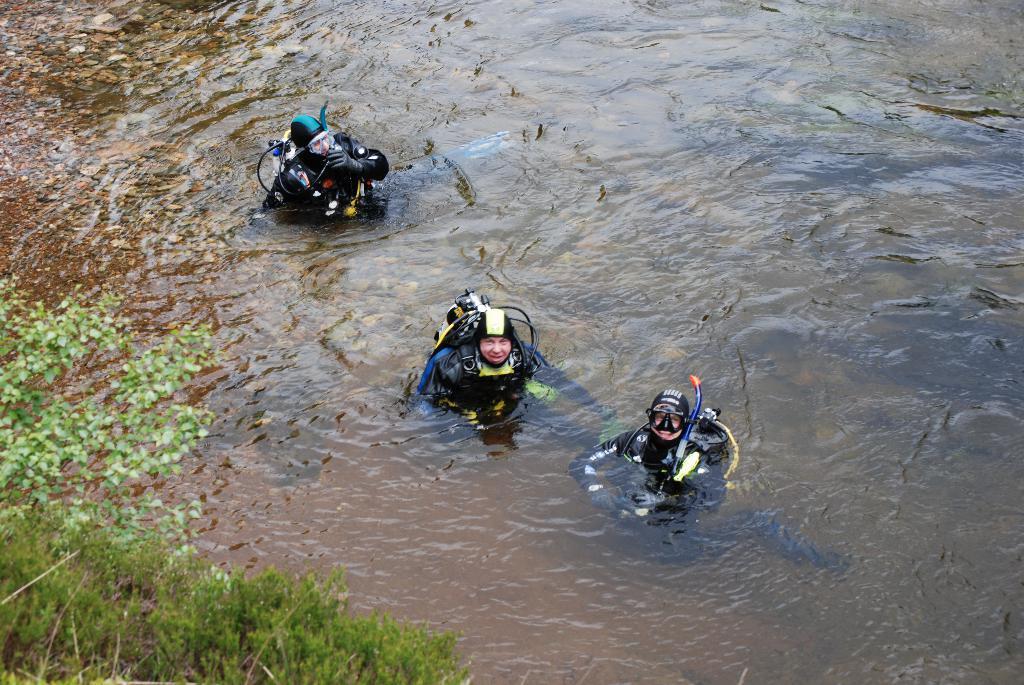Can you describe this image briefly? In this image we can see some people in a water body. We can also see some plants. 